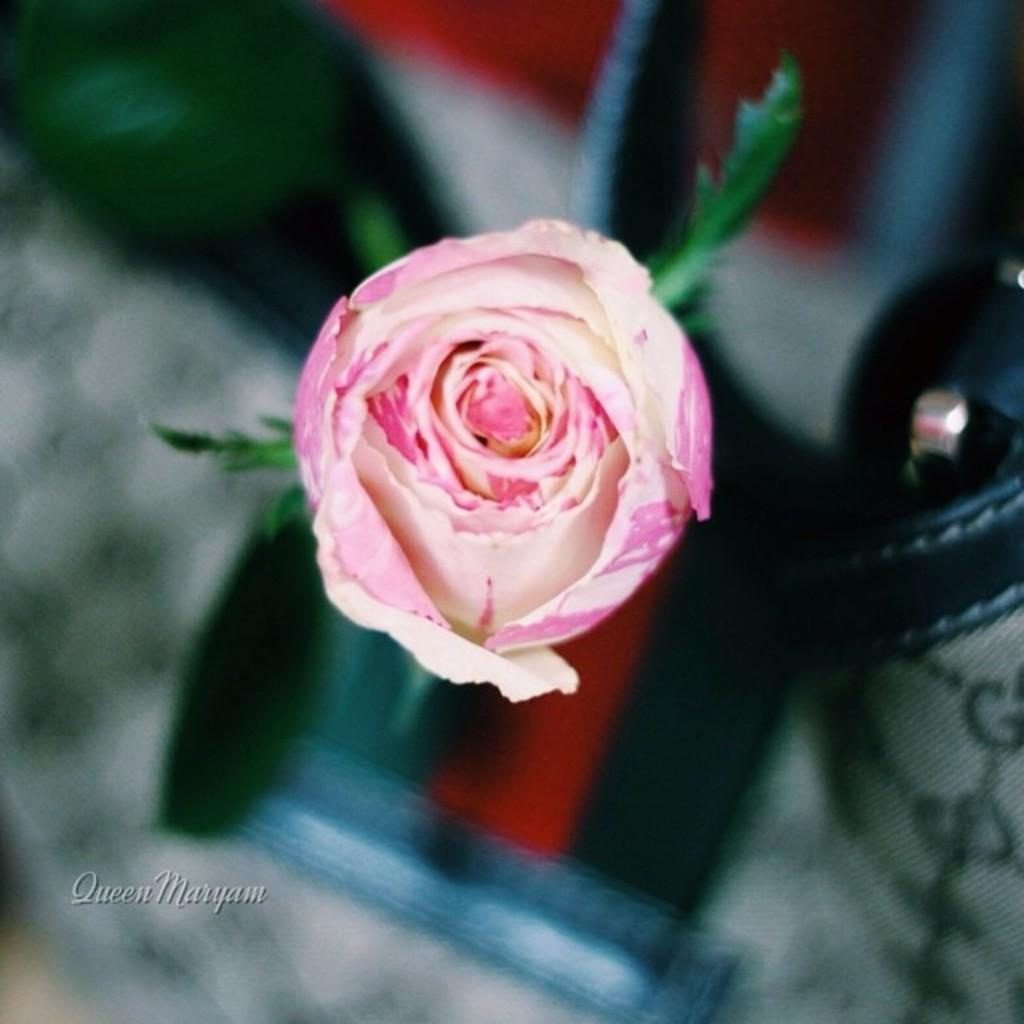What is the main subject of the image? There is a rose flower in the middle of the image. How would you describe the background of the image? The background of the image is blurry. Is there any text present in the image? Yes, there is some text at the left bottom of the image. What type of creature is holding the hook in the image? There is no hook or creature present in the image; it features a rose flower and blurry background. 